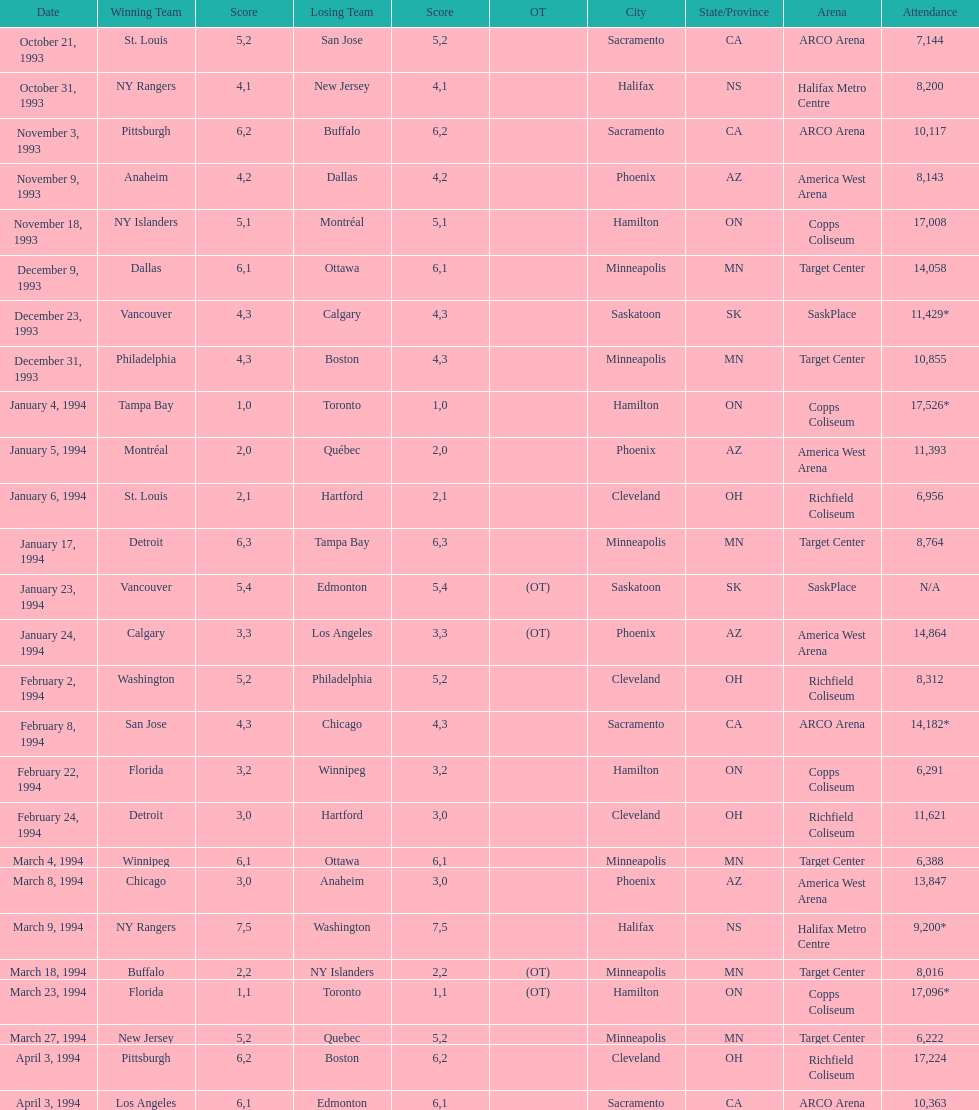How many contests have taken place in minneapolis? 6. 